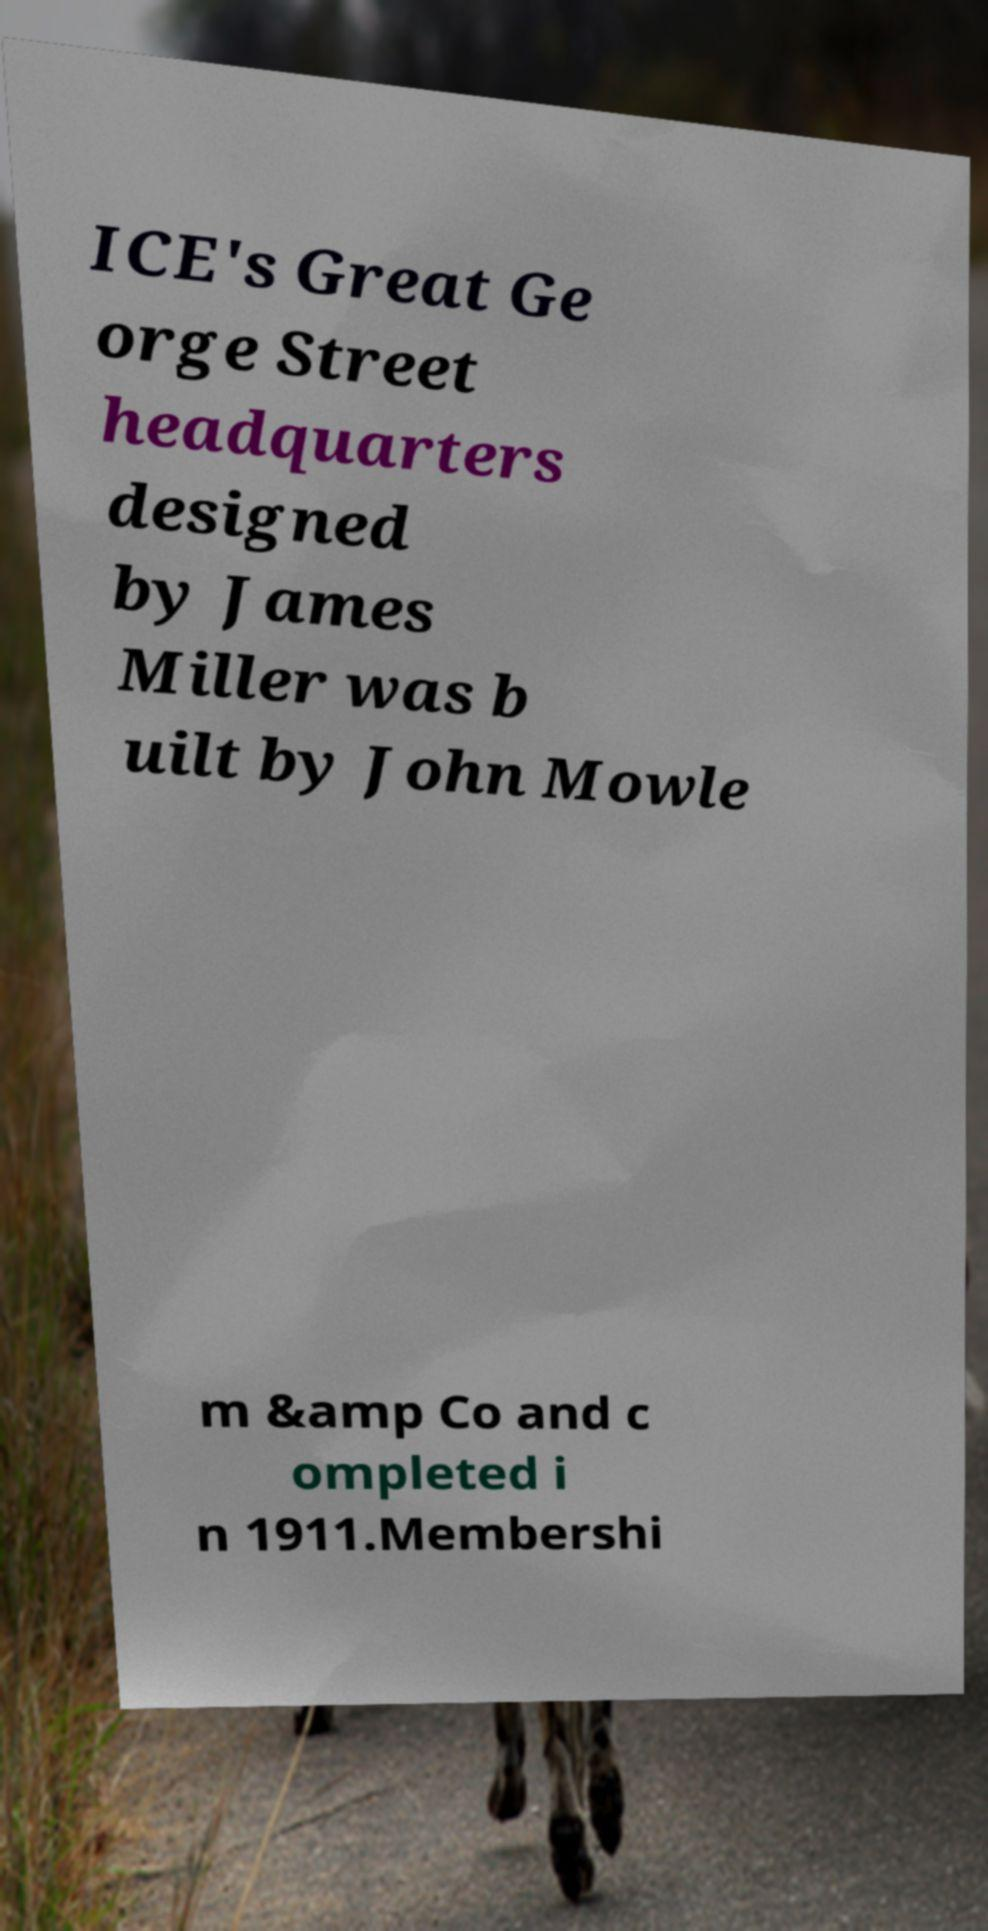Can you accurately transcribe the text from the provided image for me? ICE's Great Ge orge Street headquarters designed by James Miller was b uilt by John Mowle m &amp Co and c ompleted i n 1911.Membershi 